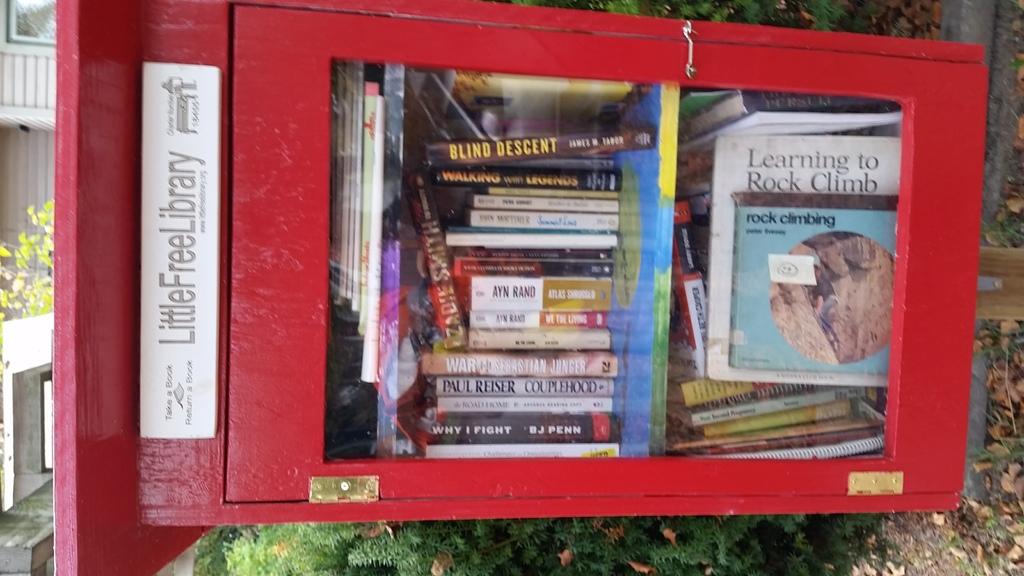What's the name of the library on the red box?
Keep it short and to the point. Little free library. 